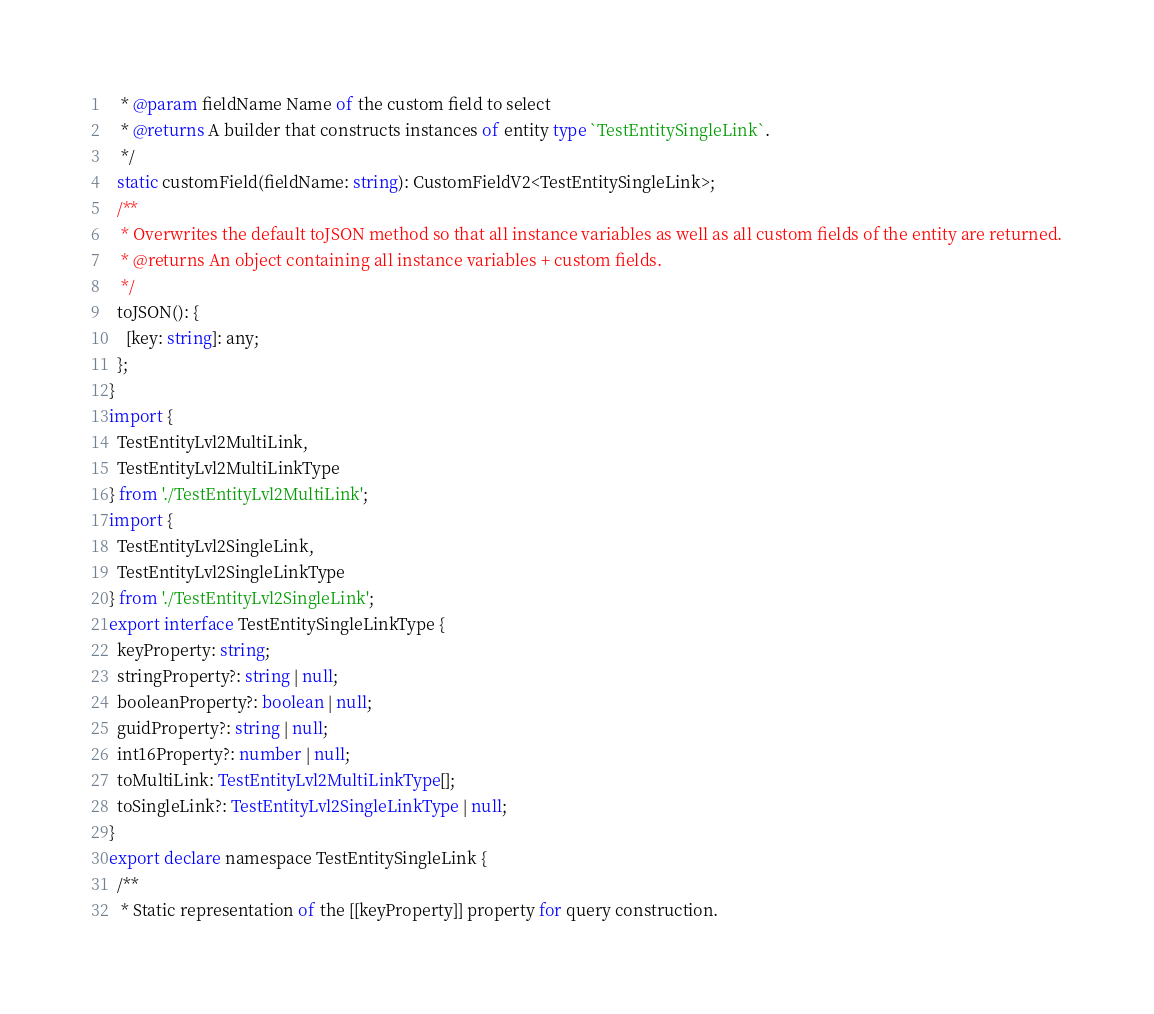Convert code to text. <code><loc_0><loc_0><loc_500><loc_500><_TypeScript_>   * @param fieldName Name of the custom field to select
   * @returns A builder that constructs instances of entity type `TestEntitySingleLink`.
   */
  static customField(fieldName: string): CustomFieldV2<TestEntitySingleLink>;
  /**
   * Overwrites the default toJSON method so that all instance variables as well as all custom fields of the entity are returned.
   * @returns An object containing all instance variables + custom fields.
   */
  toJSON(): {
    [key: string]: any;
  };
}
import {
  TestEntityLvl2MultiLink,
  TestEntityLvl2MultiLinkType
} from './TestEntityLvl2MultiLink';
import {
  TestEntityLvl2SingleLink,
  TestEntityLvl2SingleLinkType
} from './TestEntityLvl2SingleLink';
export interface TestEntitySingleLinkType {
  keyProperty: string;
  stringProperty?: string | null;
  booleanProperty?: boolean | null;
  guidProperty?: string | null;
  int16Property?: number | null;
  toMultiLink: TestEntityLvl2MultiLinkType[];
  toSingleLink?: TestEntityLvl2SingleLinkType | null;
}
export declare namespace TestEntitySingleLink {
  /**
   * Static representation of the [[keyProperty]] property for query construction.</code> 